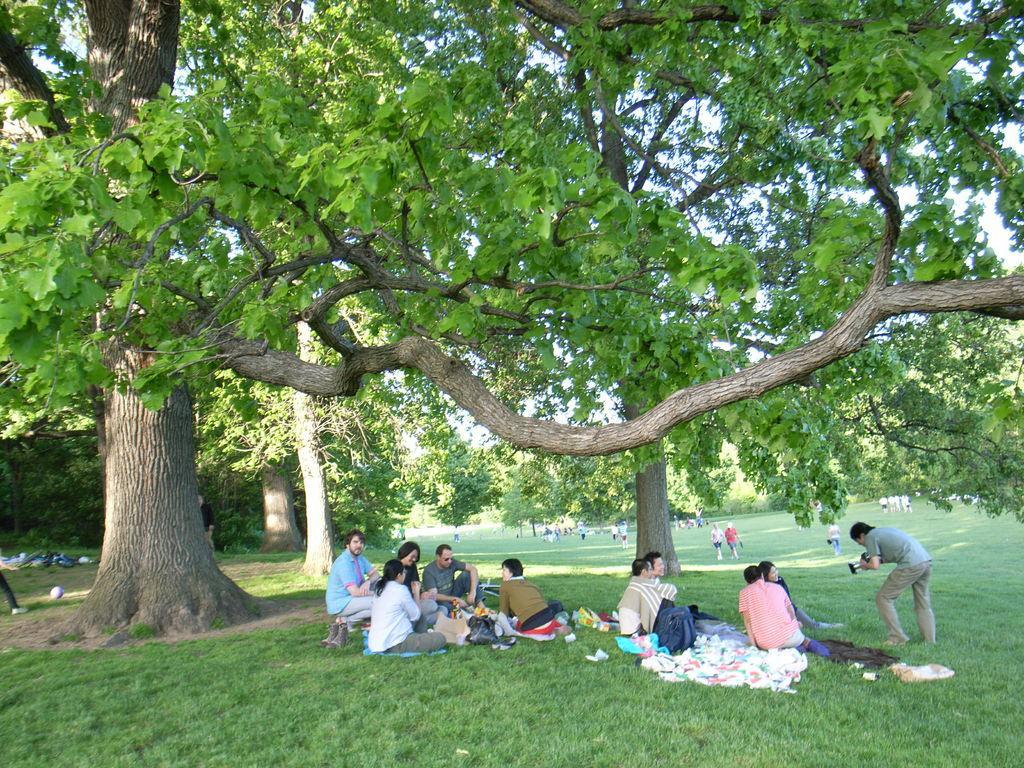Could you give a brief overview of what you see in this image? In this picture I can see the grass on which there are number of people and I can see number of trees. In the background I can see the sky. 